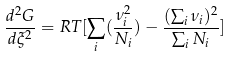<formula> <loc_0><loc_0><loc_500><loc_500>\frac { d ^ { 2 } G } { d \xi ^ { 2 } } = R T [ \sum _ { i } ( \frac { \nu ^ { 2 } _ { i } } { N _ { i } } ) - \frac { ( \sum _ { i } \nu _ { i } ) ^ { 2 } } { \sum _ { i } N _ { i } } ]</formula> 